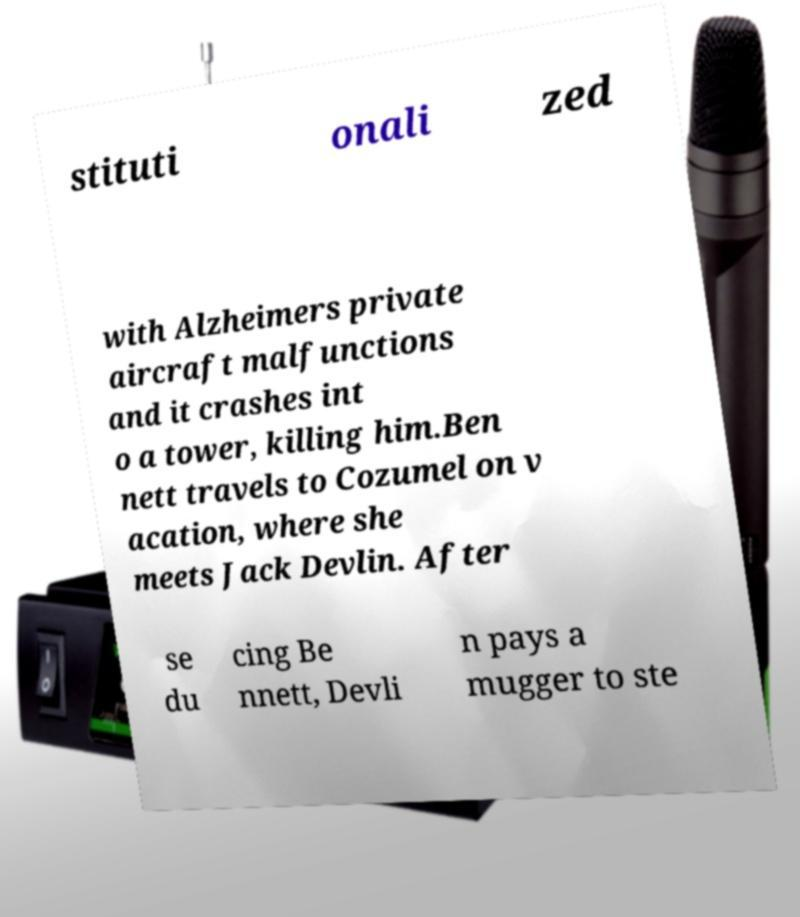Can you accurately transcribe the text from the provided image for me? stituti onali zed with Alzheimers private aircraft malfunctions and it crashes int o a tower, killing him.Ben nett travels to Cozumel on v acation, where she meets Jack Devlin. After se du cing Be nnett, Devli n pays a mugger to ste 